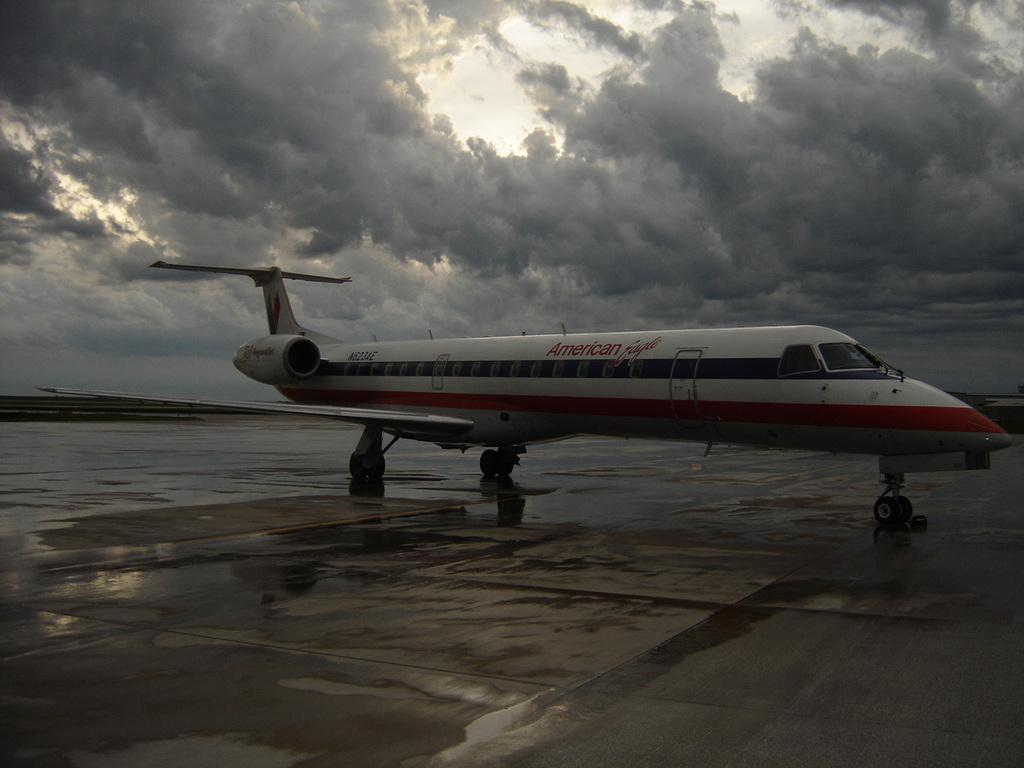What is the main subject of the image? There is an aeroplane in the center of the image. What can be seen at the bottom of the image? There is a runway at the bottom of the image. What is visible in the background of the image? The sky is visible in the background of the image. Can you see a bridge in the image? No, there is no bridge present in the image. Are there any cats visible in the image? No, there are no cats present in the image. 